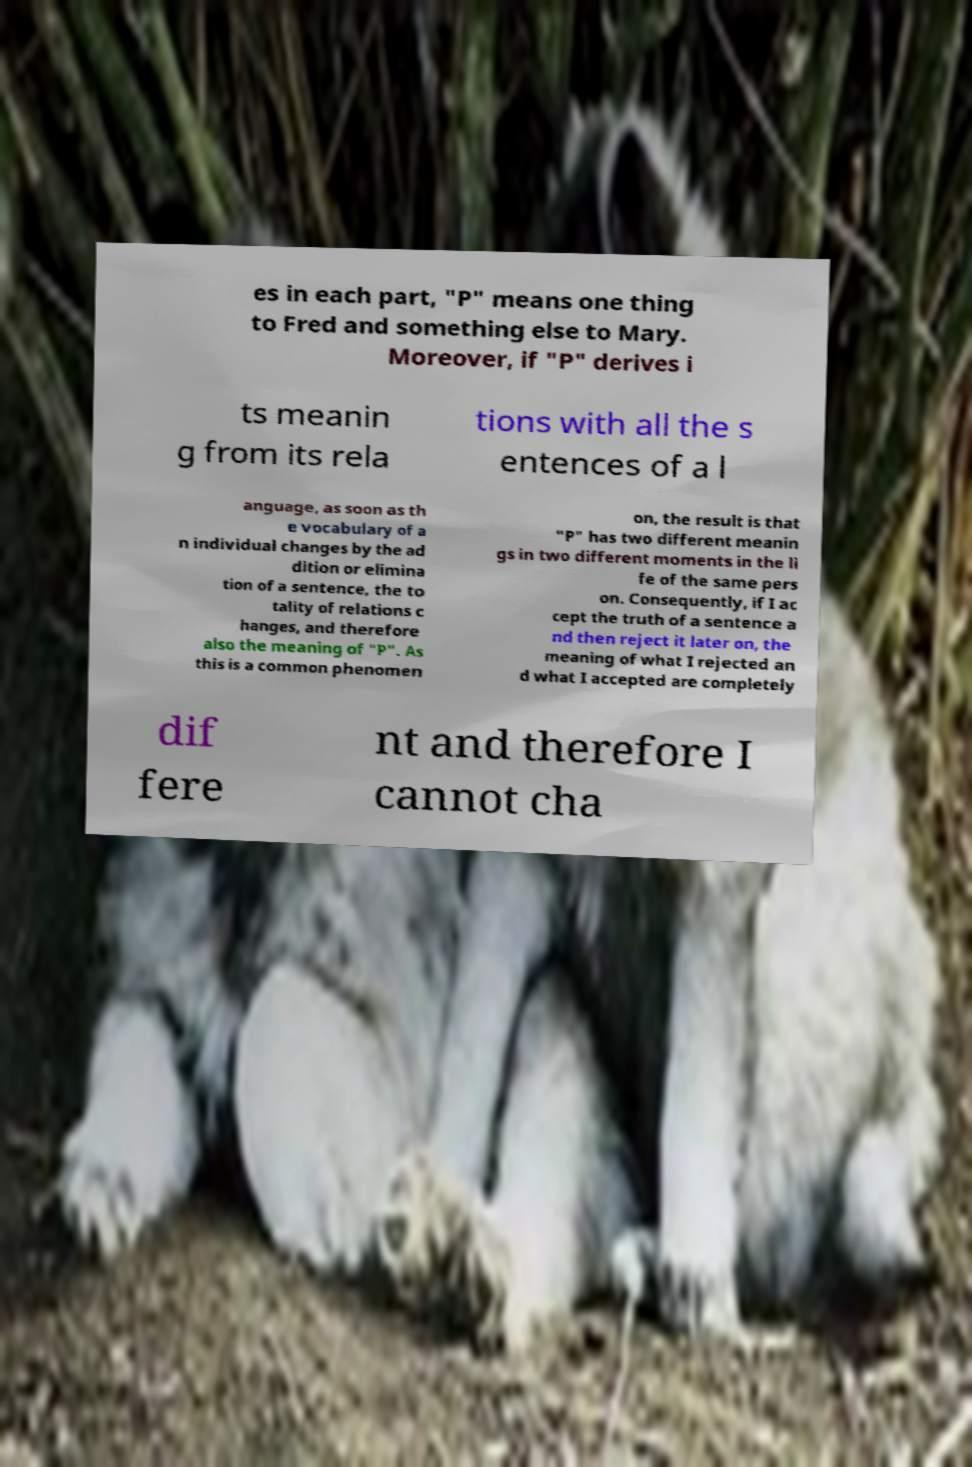Can you accurately transcribe the text from the provided image for me? es in each part, "P" means one thing to Fred and something else to Mary. Moreover, if "P" derives i ts meanin g from its rela tions with all the s entences of a l anguage, as soon as th e vocabulary of a n individual changes by the ad dition or elimina tion of a sentence, the to tality of relations c hanges, and therefore also the meaning of "P". As this is a common phenomen on, the result is that "P" has two different meanin gs in two different moments in the li fe of the same pers on. Consequently, if I ac cept the truth of a sentence a nd then reject it later on, the meaning of what I rejected an d what I accepted are completely dif fere nt and therefore I cannot cha 